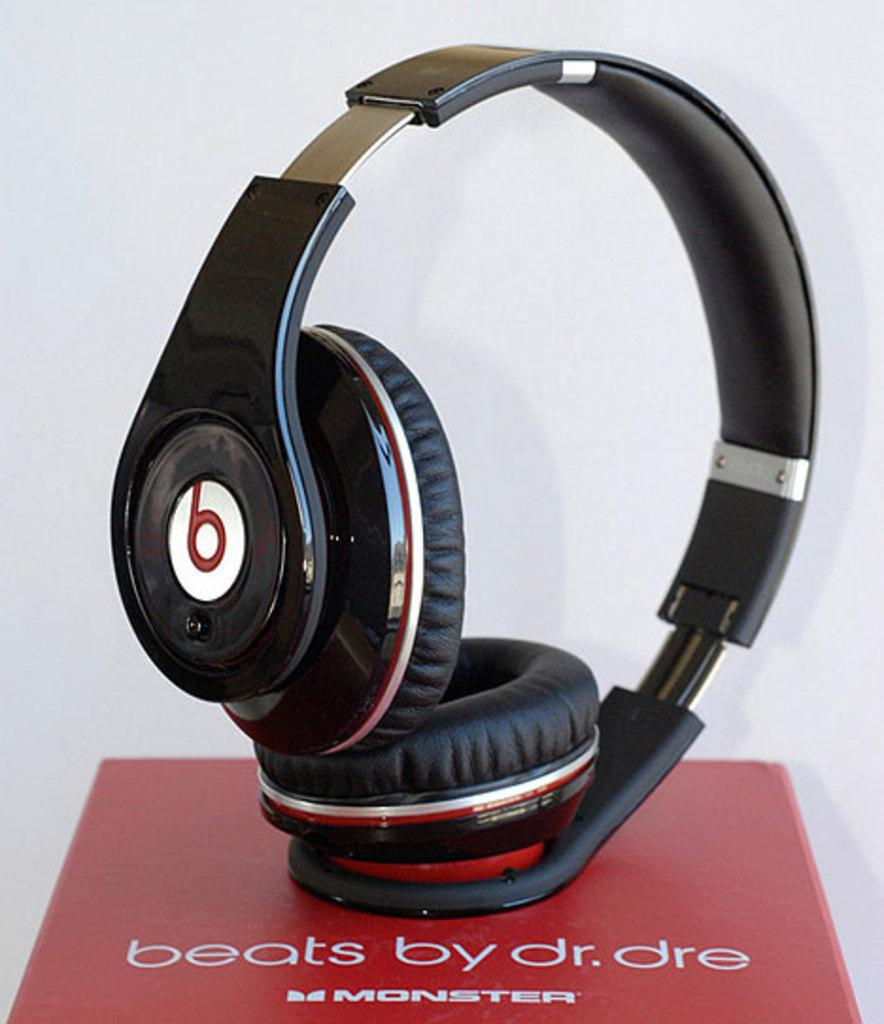What can be seen in the image related to audio equipment? There is a headphone in the image. Where is the headphone placed? The headphone is on a box. What is written or printed on the box? There is text on the box. What is the color of the background in the image? The background of the image is white. How many cakes are displayed on the box in the image? There are no cakes present in the image; it features a headphone on a box with text. Is there a bomb visible in the image? No, there is no bomb present in the image. 